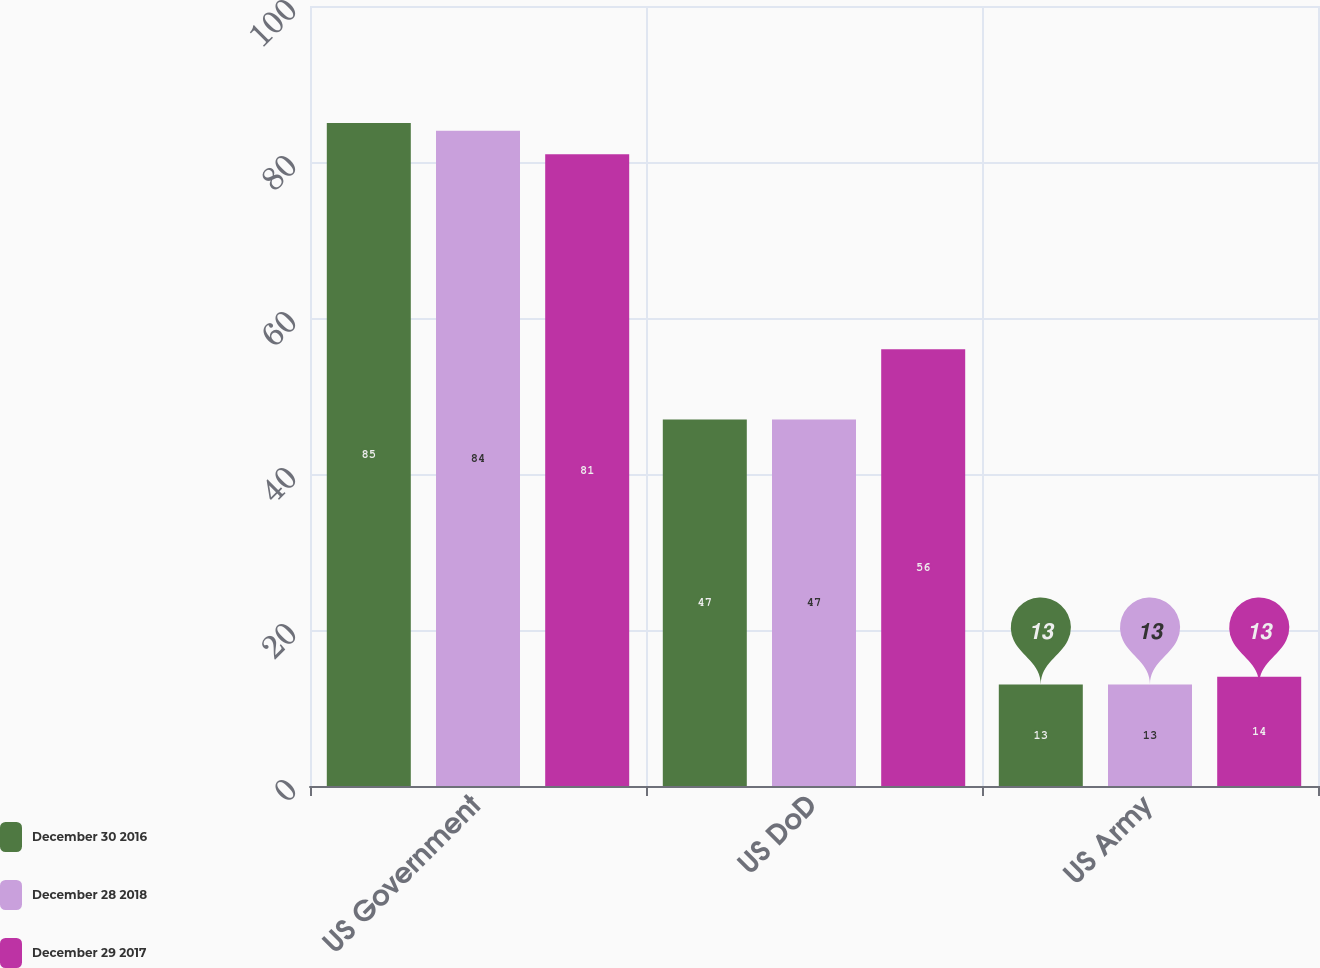Convert chart. <chart><loc_0><loc_0><loc_500><loc_500><stacked_bar_chart><ecel><fcel>US Government<fcel>US DoD<fcel>US Army<nl><fcel>December 30 2016<fcel>85<fcel>47<fcel>13<nl><fcel>December 28 2018<fcel>84<fcel>47<fcel>13<nl><fcel>December 29 2017<fcel>81<fcel>56<fcel>14<nl></chart> 